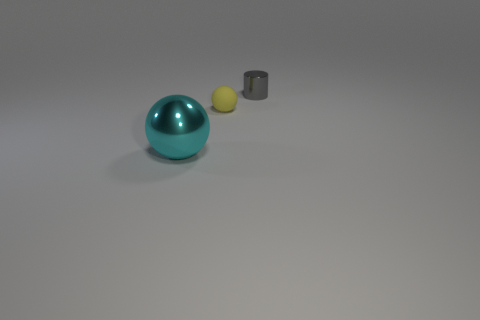Add 1 tiny red cubes. How many objects exist? 4 Subtract all cylinders. How many objects are left? 2 Add 3 small rubber balls. How many small rubber balls are left? 4 Add 2 big cyan rubber things. How many big cyan rubber things exist? 2 Subtract 0 cyan cylinders. How many objects are left? 3 Subtract all big shiny objects. Subtract all spheres. How many objects are left? 0 